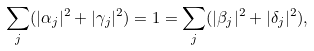Convert formula to latex. <formula><loc_0><loc_0><loc_500><loc_500>\sum _ { j } ( | \alpha _ { j } | ^ { 2 } + | \gamma _ { j } | ^ { 2 } ) = 1 = \sum _ { j } ( | \beta _ { j } | ^ { 2 } + | \delta _ { j } | ^ { 2 } ) ,</formula> 